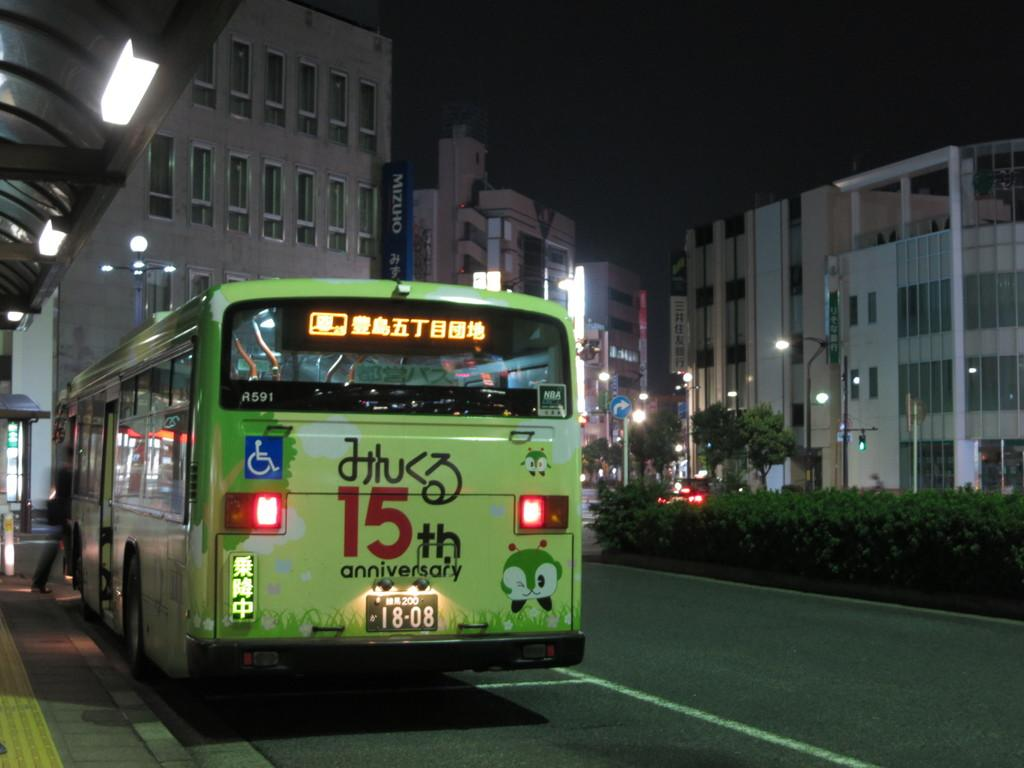<image>
Present a compact description of the photo's key features. Bus that is handicap compatible that says 15th Anniversary on the front, license plate says 18-08. 